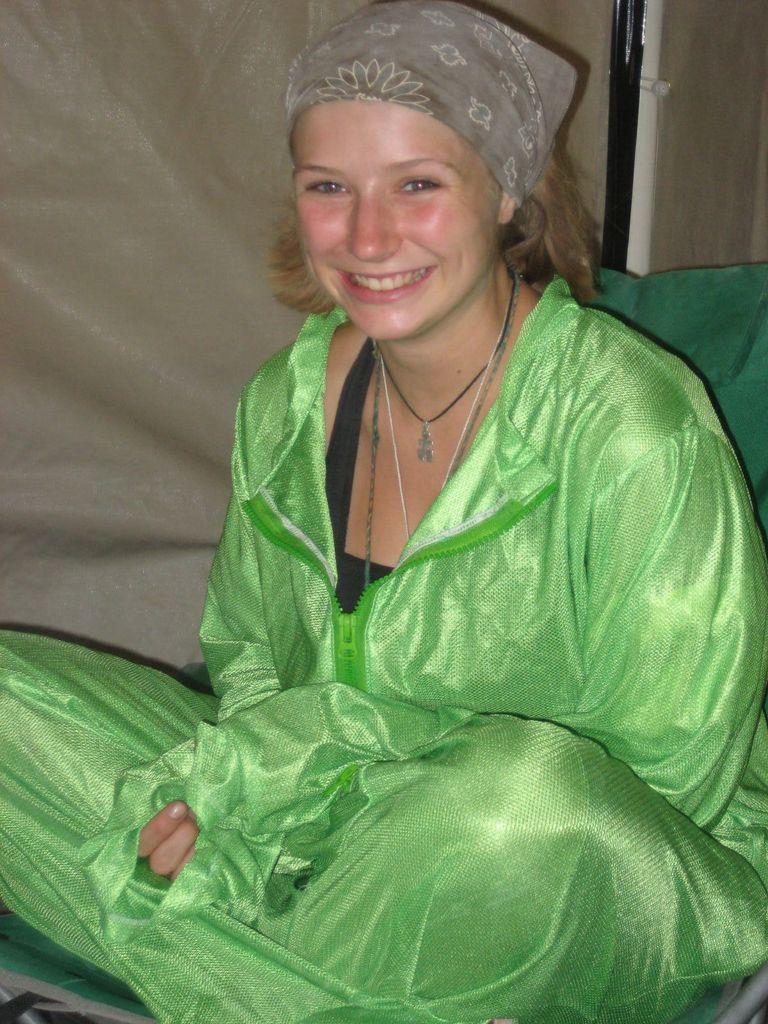In one or two sentences, can you explain what this image depicts? In the picture we can see a woman sitting and smiling, she is wearing a green color dress and behind her we can see a curtain which is cream in color. 